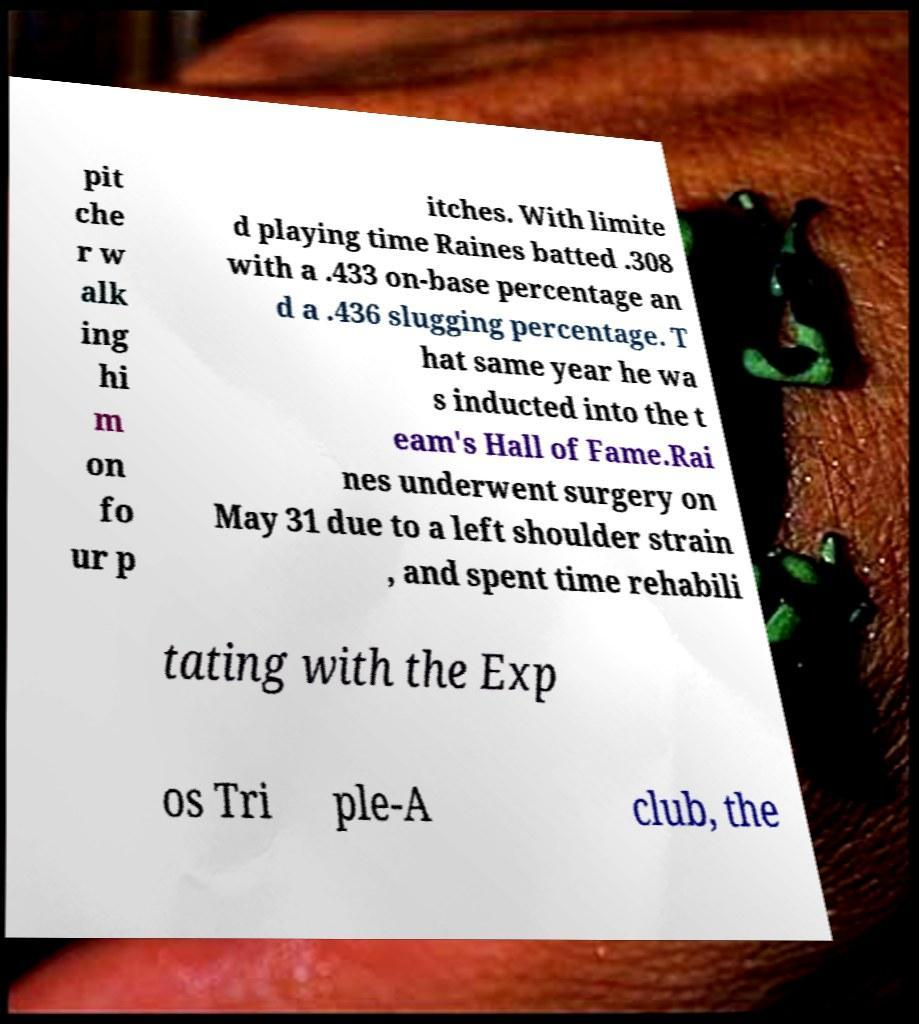For documentation purposes, I need the text within this image transcribed. Could you provide that? pit che r w alk ing hi m on fo ur p itches. With limite d playing time Raines batted .308 with a .433 on-base percentage an d a .436 slugging percentage. T hat same year he wa s inducted into the t eam's Hall of Fame.Rai nes underwent surgery on May 31 due to a left shoulder strain , and spent time rehabili tating with the Exp os Tri ple-A club, the 